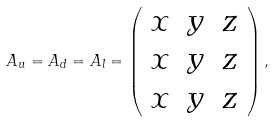Convert formula to latex. <formula><loc_0><loc_0><loc_500><loc_500>A _ { u } = A _ { d } = A _ { l } = \left ( \begin{array} { c c c } x & y & z \\ x & y & z \\ x & y & z \end{array} \right ) ,</formula> 